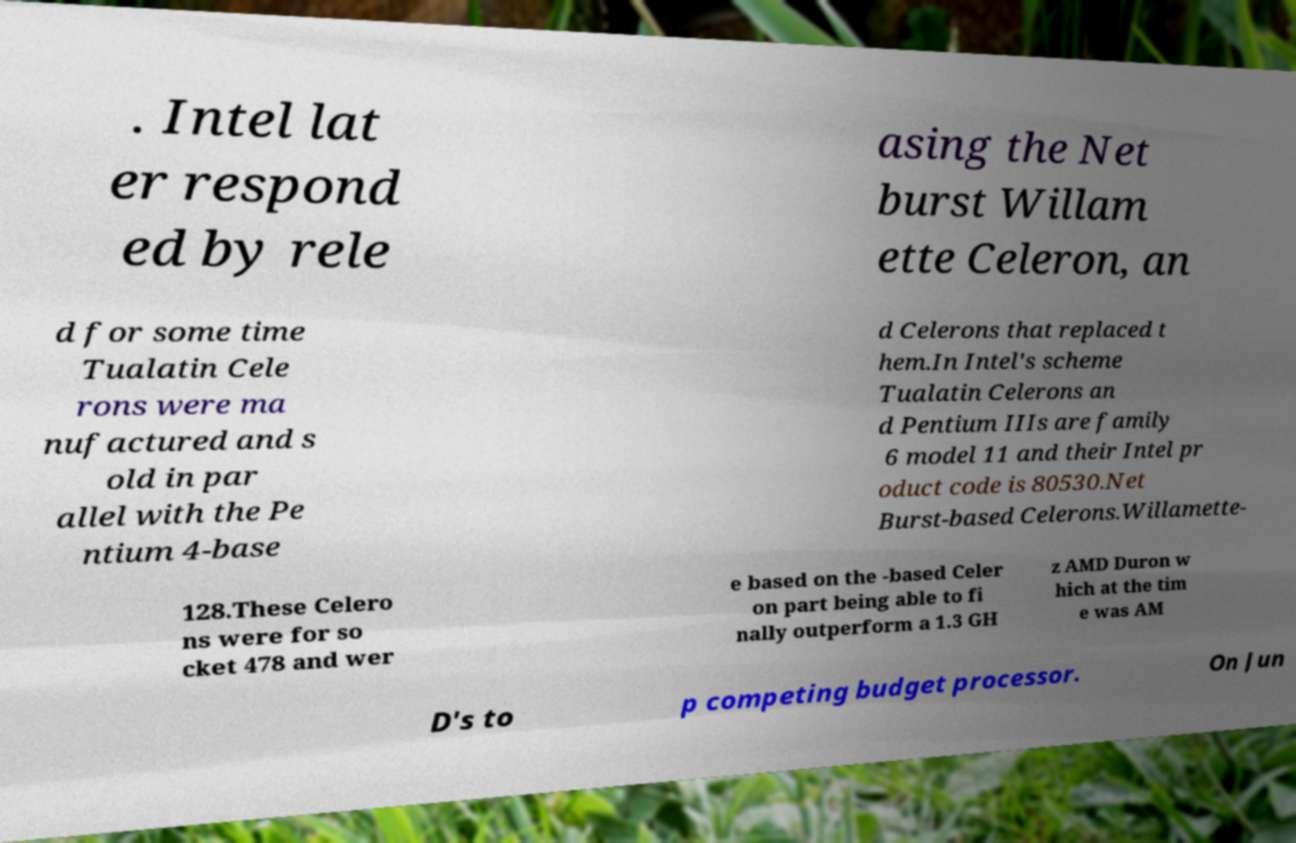What messages or text are displayed in this image? I need them in a readable, typed format. . Intel lat er respond ed by rele asing the Net burst Willam ette Celeron, an d for some time Tualatin Cele rons were ma nufactured and s old in par allel with the Pe ntium 4-base d Celerons that replaced t hem.In Intel's scheme Tualatin Celerons an d Pentium IIIs are family 6 model 11 and their Intel pr oduct code is 80530.Net Burst-based Celerons.Willamette- 128.These Celero ns were for so cket 478 and wer e based on the -based Celer on part being able to fi nally outperform a 1.3 GH z AMD Duron w hich at the tim e was AM D's to p competing budget processor. On Jun 